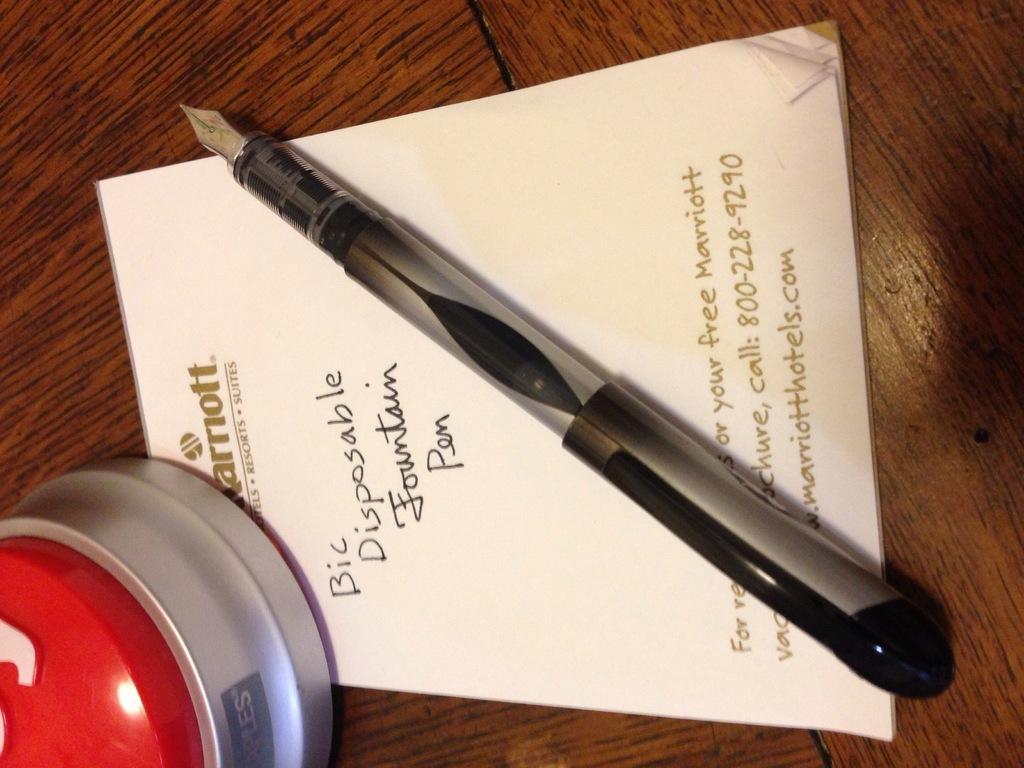Please provide a concise description of this image. This is a zoomed in picture. In the center there is a wooden table on the top of which a ball pen, papers and an object is placed and we can see the text on the paper. 